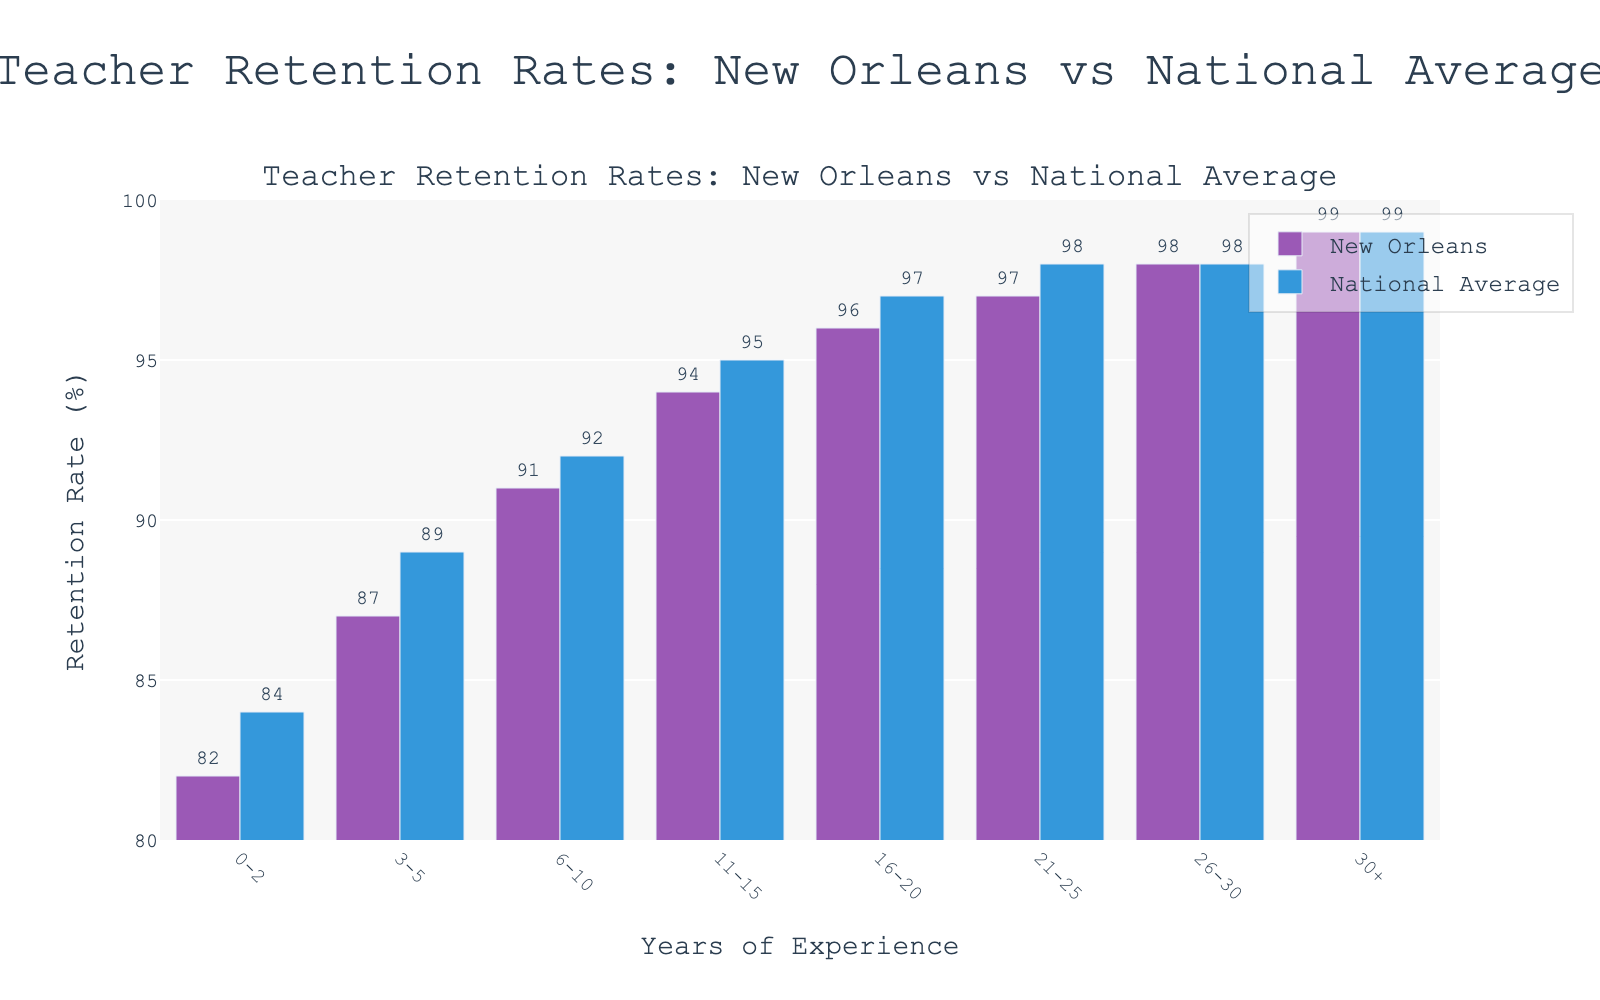Which group has the highest retention rate in New Orleans? The bar representing the 30+ years of experience group reaches the highest point on the graph.
Answer: 30+ Which group shows the smallest difference in retention rates between New Orleans and the national average? The 26-30 and 30+ years of experience groups have the same retention rates for both New Orleans and the national average, indicating the smallest difference.
Answer: 26-30 and 30+ What is the trend in retention rates as years of experience increase in New Orleans? The retention rates consistently increase as the years of experience increase, shown by the bars getting higher from left to right.
Answer: Increasing How does the retention rate for teachers with 3-5 years of experience in New Orleans compare to the national average for the same group? The bars for 3-5 years of experience show that the retention rate is 2% lower in New Orleans compared to the national average (87% vs 89%).
Answer: 2% lower Which years of experience category shows the highest difference in retention rates between New Orleans and the national average? The 0-2 years of experience category has a 2% difference, as New Orleans has an 82% retention rate, and the national average is 84%.
Answer: 0-2 Calculate the average retention rate for New Orleans teachers with 0-10 years of experience. Add the retention rates for 0-2, 3-5, and 6-10 years of experience (82 + 87 + 91) and divide by 3, yielding an average of 260 / 3 = 86.67%.
Answer: 86.67% Is there any category where New Orleans retention rates are equal to the national average? For the 26-30 years of experience and 30+ years of experience categories, both New Orleans and the national average retention rates are the same (98% and 99% respectively).
Answer: Yes How does the retention rate for teachers with 11-15 years of experience in New Orleans compare to the national average for the same group? The bars indicate that the retention rate for New Orleans is 94% compared to the national average of 95%, showing a 1% difference.
Answer: 1% lower What is the total retention rate difference between New Orleans and the national average for all categories combined? Sum the differences for each category: (84-82) + (89-87) + (92-91) + (95-94) + (97-96) + (98-97) + 0 + 0 = 8%.
Answer: 8% 